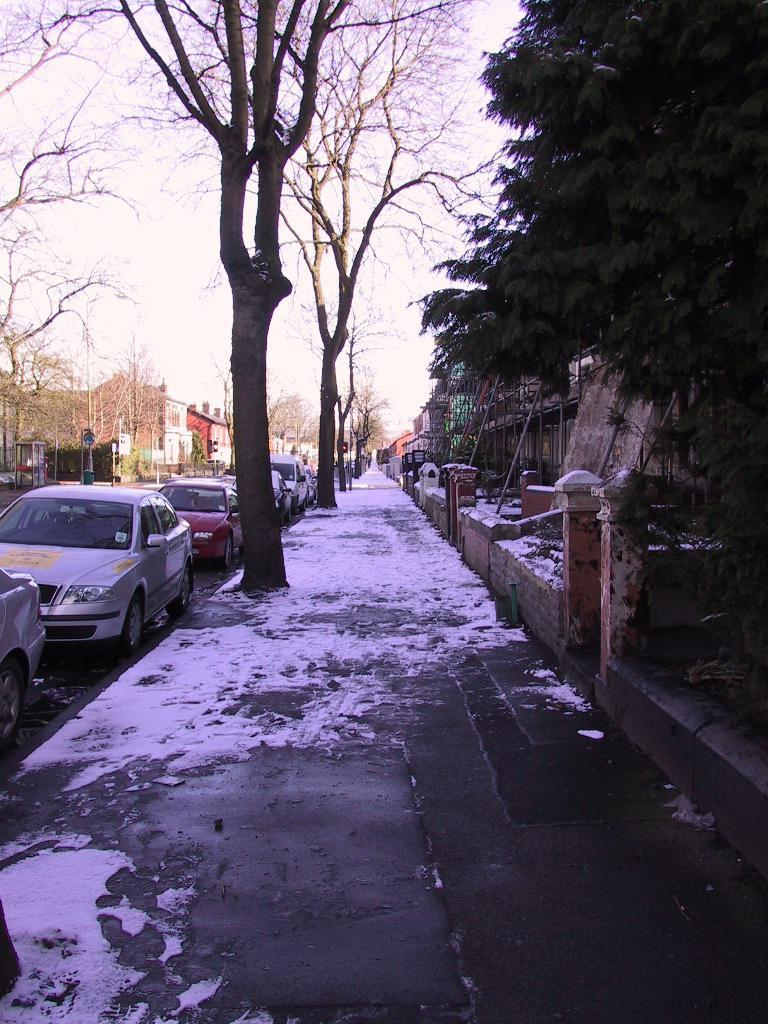What type of vehicles can be seen in the image? There are cars in the image. What other objects or features are present in the image? There are trees and houses in the image. What is the condition of the road in the image? There is snow on the road in the image. What is visible at the top of the image? The sky is visible at the top of the image. What type of hat is the tree wearing in the image? There are no hats present in the image, as trees do not wear hats. What kind of haircut does the snow on the road have in the image? There is no hair present in the image, as snow does not have a haircut. 